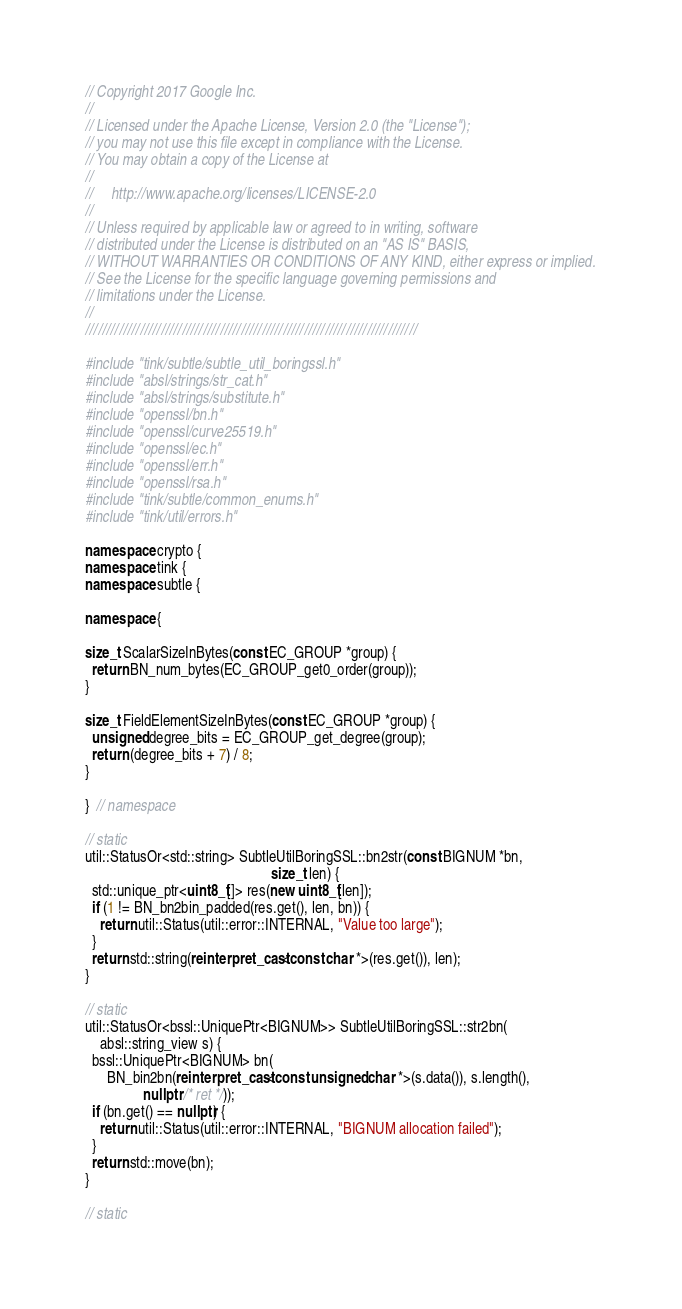<code> <loc_0><loc_0><loc_500><loc_500><_C++_>// Copyright 2017 Google Inc.
//
// Licensed under the Apache License, Version 2.0 (the "License");
// you may not use this file except in compliance with the License.
// You may obtain a copy of the License at
//
//     http://www.apache.org/licenses/LICENSE-2.0
//
// Unless required by applicable law or agreed to in writing, software
// distributed under the License is distributed on an "AS IS" BASIS,
// WITHOUT WARRANTIES OR CONDITIONS OF ANY KIND, either express or implied.
// See the License for the specific language governing permissions and
// limitations under the License.
//
///////////////////////////////////////////////////////////////////////////////

#include "tink/subtle/subtle_util_boringssl.h"
#include "absl/strings/str_cat.h"
#include "absl/strings/substitute.h"
#include "openssl/bn.h"
#include "openssl/curve25519.h"
#include "openssl/ec.h"
#include "openssl/err.h"
#include "openssl/rsa.h"
#include "tink/subtle/common_enums.h"
#include "tink/util/errors.h"

namespace crypto {
namespace tink {
namespace subtle {

namespace {

size_t ScalarSizeInBytes(const EC_GROUP *group) {
  return BN_num_bytes(EC_GROUP_get0_order(group));
}

size_t FieldElementSizeInBytes(const EC_GROUP *group) {
  unsigned degree_bits = EC_GROUP_get_degree(group);
  return (degree_bits + 7) / 8;
}

}  // namespace

// static
util::StatusOr<std::string> SubtleUtilBoringSSL::bn2str(const BIGNUM *bn,
                                                   size_t len) {
  std::unique_ptr<uint8_t[]> res(new uint8_t[len]);
  if (1 != BN_bn2bin_padded(res.get(), len, bn)) {
    return util::Status(util::error::INTERNAL, "Value too large");
  }
  return std::string(reinterpret_cast<const char *>(res.get()), len);
}

// static
util::StatusOr<bssl::UniquePtr<BIGNUM>> SubtleUtilBoringSSL::str2bn(
    absl::string_view s) {
  bssl::UniquePtr<BIGNUM> bn(
      BN_bin2bn(reinterpret_cast<const unsigned char *>(s.data()), s.length(),
                nullptr /* ret */));
  if (bn.get() == nullptr) {
    return util::Status(util::error::INTERNAL, "BIGNUM allocation failed");
  }
  return std::move(bn);
}

// static</code> 